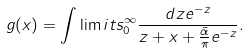Convert formula to latex. <formula><loc_0><loc_0><loc_500><loc_500>g ( x ) = \int \lim i t s _ { 0 } ^ { \infty } \frac { d z e ^ { - z } } { z + x + \frac { \bar { \alpha } } { \pi } e ^ { - z } } .</formula> 